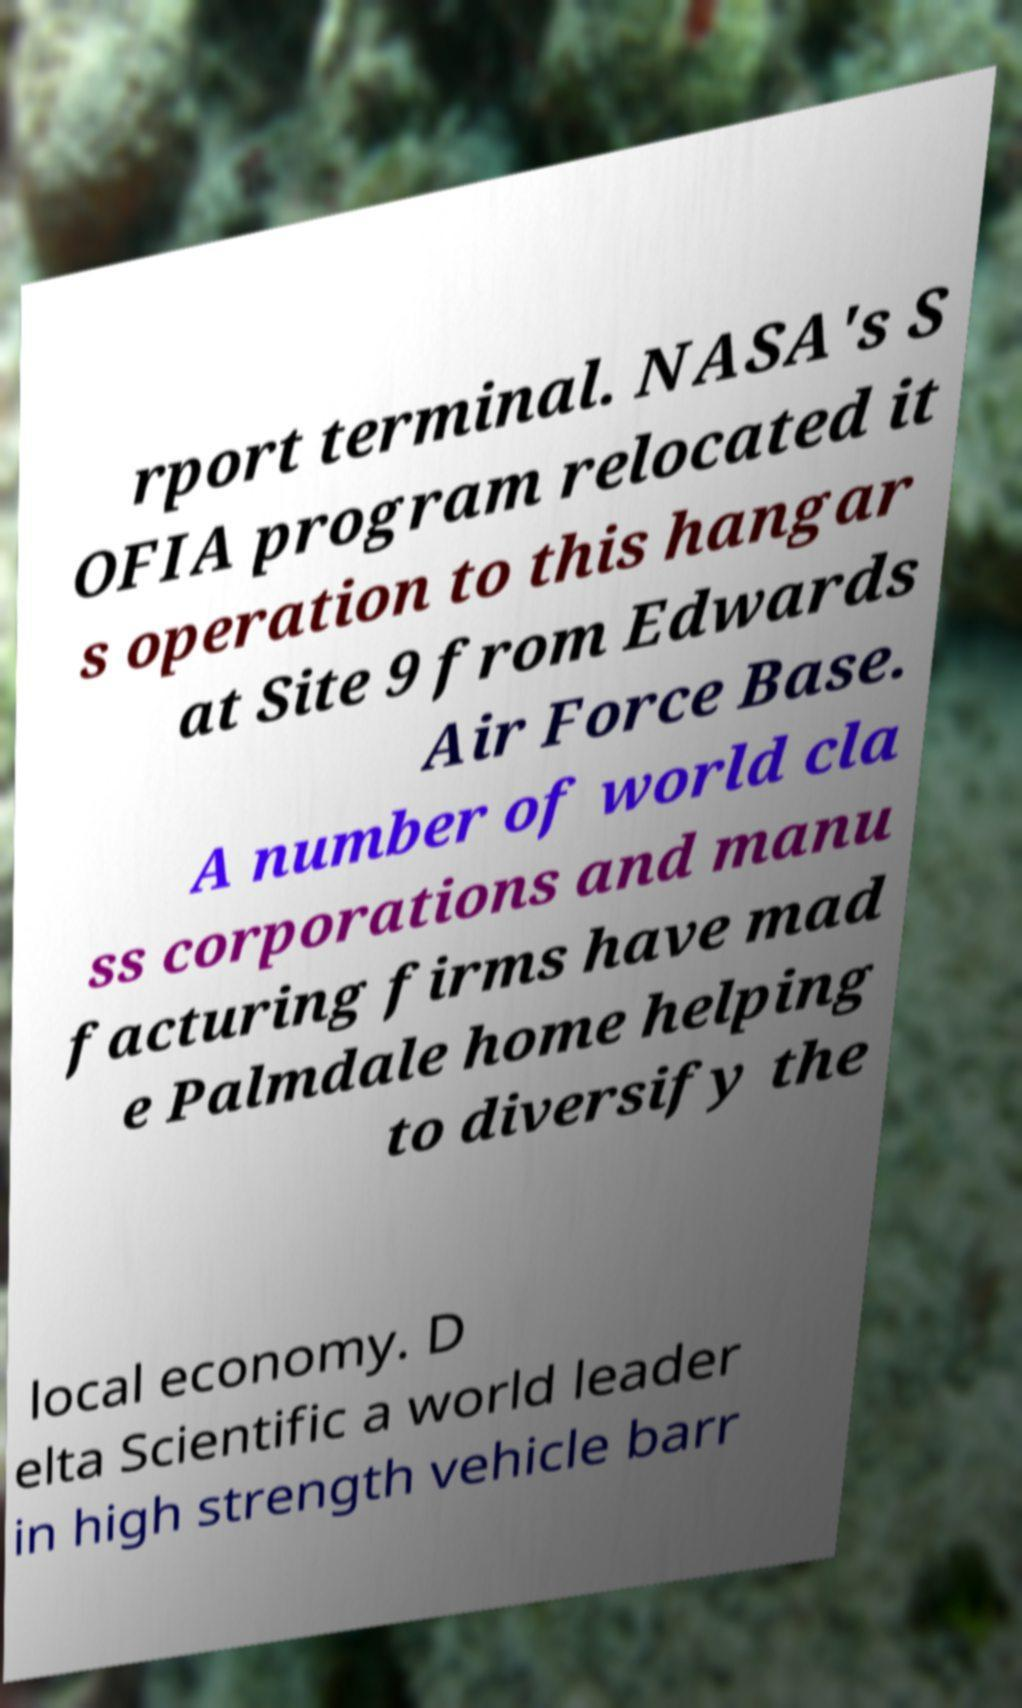I need the written content from this picture converted into text. Can you do that? rport terminal. NASA's S OFIA program relocated it s operation to this hangar at Site 9 from Edwards Air Force Base. A number of world cla ss corporations and manu facturing firms have mad e Palmdale home helping to diversify the local economy. D elta Scientific a world leader in high strength vehicle barr 